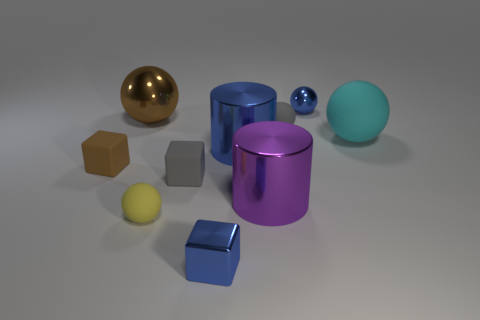Are there fewer tiny matte spheres than cyan rubber balls?
Your response must be concise. No. What material is the big sphere right of the metal sphere that is in front of the tiny shiny sphere made of?
Offer a terse response. Rubber. Is the size of the brown shiny thing the same as the gray ball?
Offer a terse response. No. What number of things are large brown spheres or blue cylinders?
Your answer should be very brief. 2. How big is the blue metal thing that is behind the metallic block and in front of the big brown object?
Ensure brevity in your answer.  Large. Is the number of small metallic blocks that are behind the blue ball less than the number of big purple rubber blocks?
Give a very brief answer. No. The large purple object that is made of the same material as the blue cube is what shape?
Your answer should be very brief. Cylinder. Does the small gray thing on the right side of the tiny blue block have the same shape as the tiny gray object to the left of the gray sphere?
Provide a succinct answer. No. Is the number of cylinders behind the large brown metal thing less than the number of big blue shiny cylinders that are behind the blue cylinder?
Provide a succinct answer. No. What shape is the small thing that is the same color as the metal cube?
Keep it short and to the point. Sphere. 